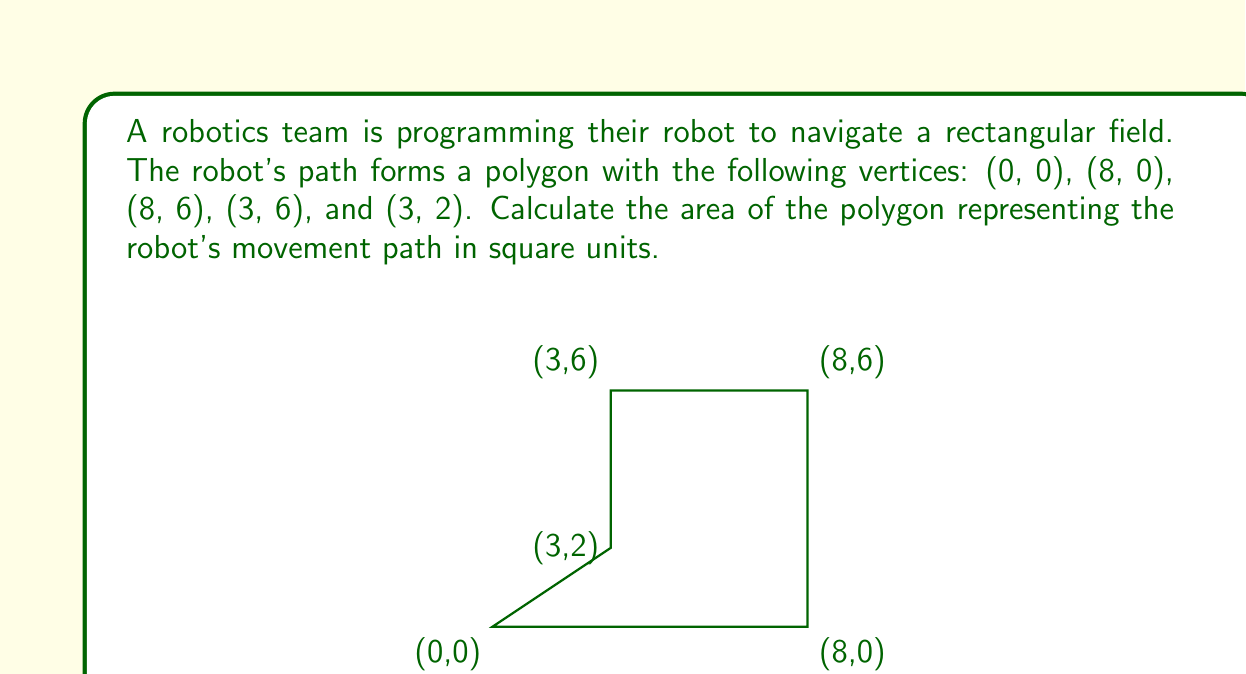Provide a solution to this math problem. To calculate the area of this irregular polygon, we can divide it into two rectangles:

1. Rectangle 1: 
   Width = 8, Height = 2
   Area of Rectangle 1 = $8 \times 2 = 16$ square units

2. Rectangle 2:
   Width = 3, Height = 4
   Area of Rectangle 2 = $3 \times 4 = 12$ square units

The total area of the polygon is the sum of these two rectangles:

$$\text{Total Area} = \text{Area of Rectangle 1} + \text{Area of Rectangle 2}$$
$$\text{Total Area} = 16 + 12 = 28\text{ square units}$$

Therefore, the area of the polygon representing the robot's movement path is 28 square units.
Answer: 28 square units 